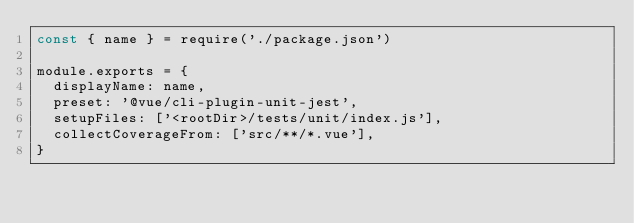Convert code to text. <code><loc_0><loc_0><loc_500><loc_500><_JavaScript_>const { name } = require('./package.json')

module.exports = {
  displayName: name,
  preset: '@vue/cli-plugin-unit-jest',
  setupFiles: ['<rootDir>/tests/unit/index.js'],
  collectCoverageFrom: ['src/**/*.vue'],
}
</code> 